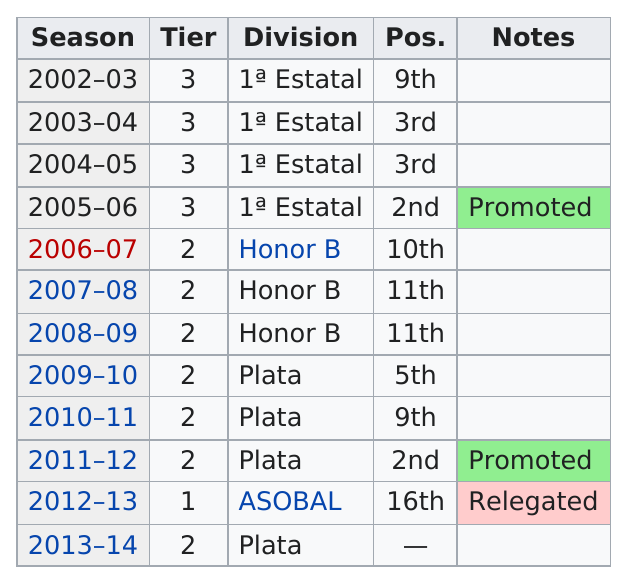Outline some significant characteristics in this image. The only season they were in the Asobal division was 2012-2013. They were promoted in 2011-12, and the previous year they were promoted was 2005-06. ASOBAL's division is listed only once. The 2011-2012 season was more successful than the 2012-2013 season. The team scored at least third in four seasons. 